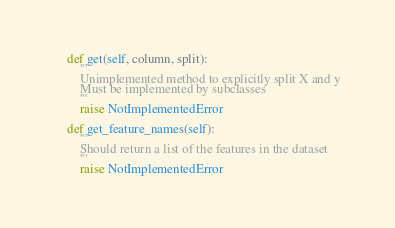<code> <loc_0><loc_0><loc_500><loc_500><_Python_>
    def get(self, column, split):
        '''
        Unimplemented method to explicitly split X and y
        Must be implemented by subclasses
        '''
        raise NotImplementedError

    def get_feature_names(self):
        '''
        Should return a list of the features in the dataset
        '''
        raise NotImplementedError
</code> 